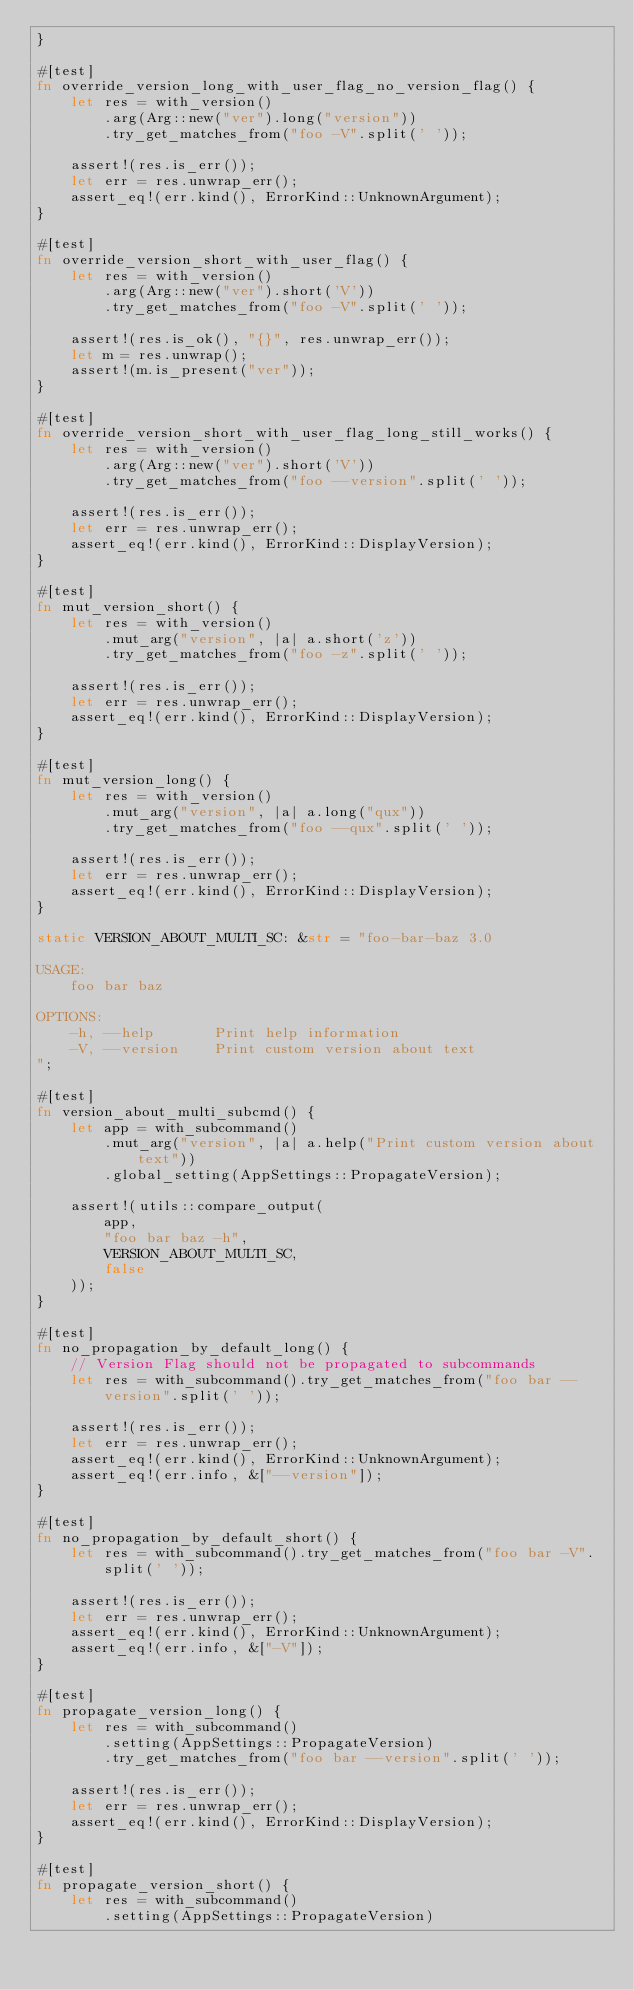Convert code to text. <code><loc_0><loc_0><loc_500><loc_500><_Rust_>}

#[test]
fn override_version_long_with_user_flag_no_version_flag() {
    let res = with_version()
        .arg(Arg::new("ver").long("version"))
        .try_get_matches_from("foo -V".split(' '));

    assert!(res.is_err());
    let err = res.unwrap_err();
    assert_eq!(err.kind(), ErrorKind::UnknownArgument);
}

#[test]
fn override_version_short_with_user_flag() {
    let res = with_version()
        .arg(Arg::new("ver").short('V'))
        .try_get_matches_from("foo -V".split(' '));

    assert!(res.is_ok(), "{}", res.unwrap_err());
    let m = res.unwrap();
    assert!(m.is_present("ver"));
}

#[test]
fn override_version_short_with_user_flag_long_still_works() {
    let res = with_version()
        .arg(Arg::new("ver").short('V'))
        .try_get_matches_from("foo --version".split(' '));

    assert!(res.is_err());
    let err = res.unwrap_err();
    assert_eq!(err.kind(), ErrorKind::DisplayVersion);
}

#[test]
fn mut_version_short() {
    let res = with_version()
        .mut_arg("version", |a| a.short('z'))
        .try_get_matches_from("foo -z".split(' '));

    assert!(res.is_err());
    let err = res.unwrap_err();
    assert_eq!(err.kind(), ErrorKind::DisplayVersion);
}

#[test]
fn mut_version_long() {
    let res = with_version()
        .mut_arg("version", |a| a.long("qux"))
        .try_get_matches_from("foo --qux".split(' '));

    assert!(res.is_err());
    let err = res.unwrap_err();
    assert_eq!(err.kind(), ErrorKind::DisplayVersion);
}

static VERSION_ABOUT_MULTI_SC: &str = "foo-bar-baz 3.0

USAGE:
    foo bar baz

OPTIONS:
    -h, --help       Print help information
    -V, --version    Print custom version about text
";

#[test]
fn version_about_multi_subcmd() {
    let app = with_subcommand()
        .mut_arg("version", |a| a.help("Print custom version about text"))
        .global_setting(AppSettings::PropagateVersion);

    assert!(utils::compare_output(
        app,
        "foo bar baz -h",
        VERSION_ABOUT_MULTI_SC,
        false
    ));
}

#[test]
fn no_propagation_by_default_long() {
    // Version Flag should not be propagated to subcommands
    let res = with_subcommand().try_get_matches_from("foo bar --version".split(' '));

    assert!(res.is_err());
    let err = res.unwrap_err();
    assert_eq!(err.kind(), ErrorKind::UnknownArgument);
    assert_eq!(err.info, &["--version"]);
}

#[test]
fn no_propagation_by_default_short() {
    let res = with_subcommand().try_get_matches_from("foo bar -V".split(' '));

    assert!(res.is_err());
    let err = res.unwrap_err();
    assert_eq!(err.kind(), ErrorKind::UnknownArgument);
    assert_eq!(err.info, &["-V"]);
}

#[test]
fn propagate_version_long() {
    let res = with_subcommand()
        .setting(AppSettings::PropagateVersion)
        .try_get_matches_from("foo bar --version".split(' '));

    assert!(res.is_err());
    let err = res.unwrap_err();
    assert_eq!(err.kind(), ErrorKind::DisplayVersion);
}

#[test]
fn propagate_version_short() {
    let res = with_subcommand()
        .setting(AppSettings::PropagateVersion)</code> 